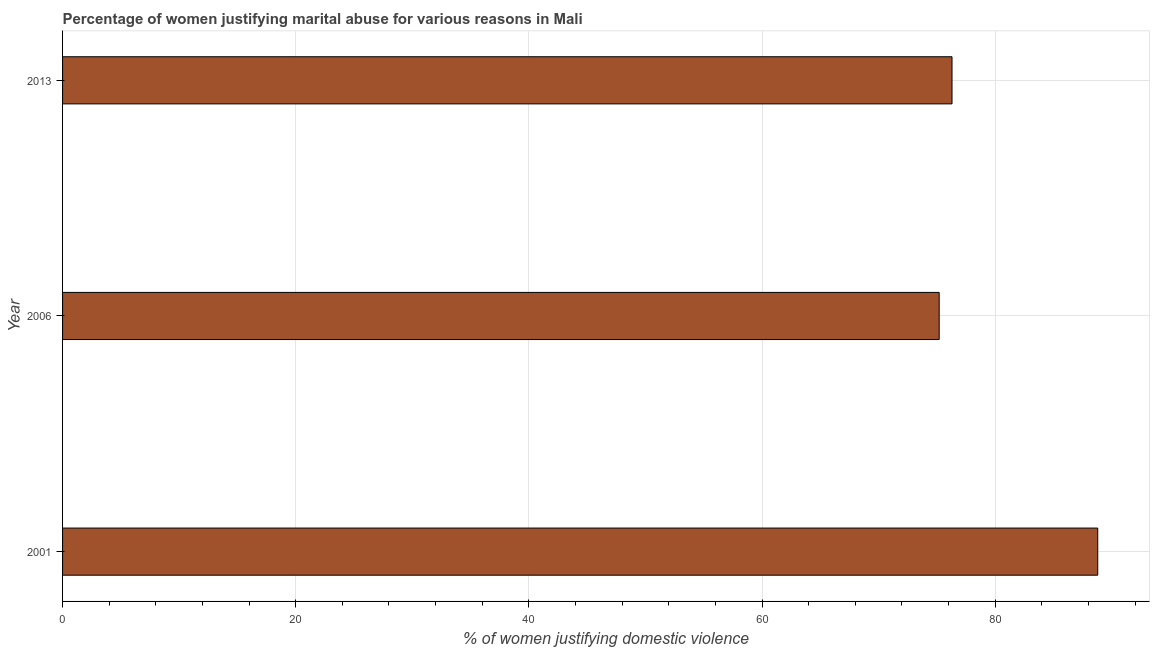What is the title of the graph?
Give a very brief answer. Percentage of women justifying marital abuse for various reasons in Mali. What is the label or title of the X-axis?
Offer a very short reply. % of women justifying domestic violence. What is the percentage of women justifying marital abuse in 2006?
Provide a short and direct response. 75.2. Across all years, what is the maximum percentage of women justifying marital abuse?
Offer a terse response. 88.8. Across all years, what is the minimum percentage of women justifying marital abuse?
Your answer should be very brief. 75.2. In which year was the percentage of women justifying marital abuse maximum?
Provide a succinct answer. 2001. In which year was the percentage of women justifying marital abuse minimum?
Offer a very short reply. 2006. What is the sum of the percentage of women justifying marital abuse?
Ensure brevity in your answer.  240.3. What is the average percentage of women justifying marital abuse per year?
Offer a very short reply. 80.1. What is the median percentage of women justifying marital abuse?
Offer a terse response. 76.3. What is the ratio of the percentage of women justifying marital abuse in 2001 to that in 2013?
Offer a terse response. 1.16. Is the percentage of women justifying marital abuse in 2001 less than that in 2006?
Offer a very short reply. No. Is the difference between the percentage of women justifying marital abuse in 2001 and 2006 greater than the difference between any two years?
Provide a succinct answer. Yes. What is the difference between the highest and the second highest percentage of women justifying marital abuse?
Give a very brief answer. 12.5. Is the sum of the percentage of women justifying marital abuse in 2001 and 2006 greater than the maximum percentage of women justifying marital abuse across all years?
Make the answer very short. Yes. What is the difference between the highest and the lowest percentage of women justifying marital abuse?
Your answer should be compact. 13.6. Are all the bars in the graph horizontal?
Provide a short and direct response. Yes. What is the difference between two consecutive major ticks on the X-axis?
Keep it short and to the point. 20. What is the % of women justifying domestic violence in 2001?
Ensure brevity in your answer.  88.8. What is the % of women justifying domestic violence in 2006?
Keep it short and to the point. 75.2. What is the % of women justifying domestic violence of 2013?
Make the answer very short. 76.3. What is the ratio of the % of women justifying domestic violence in 2001 to that in 2006?
Offer a terse response. 1.18. What is the ratio of the % of women justifying domestic violence in 2001 to that in 2013?
Offer a terse response. 1.16. What is the ratio of the % of women justifying domestic violence in 2006 to that in 2013?
Your answer should be compact. 0.99. 